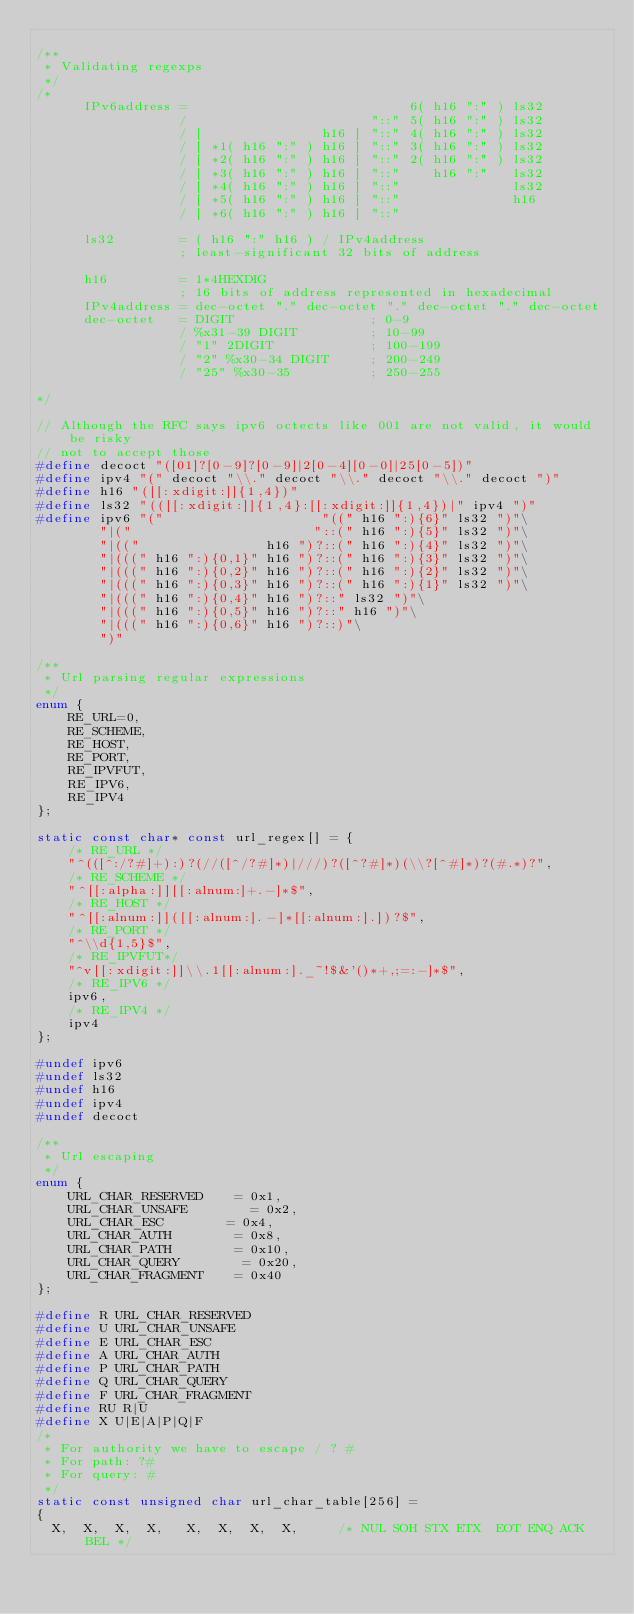<code> <loc_0><loc_0><loc_500><loc_500><_C_>
/**
 * Validating regexps
 */
/*
      IPv6address =                            6( h16 ":" ) ls32
                  /                       "::" 5( h16 ":" ) ls32
                  / [               h16 ] "::" 4( h16 ":" ) ls32
                  / [ *1( h16 ":" ) h16 ] "::" 3( h16 ":" ) ls32
                  / [ *2( h16 ":" ) h16 ] "::" 2( h16 ":" ) ls32
                  / [ *3( h16 ":" ) h16 ] "::"    h16 ":"   ls32
                  / [ *4( h16 ":" ) h16 ] "::"              ls32
                  / [ *5( h16 ":" ) h16 ] "::"              h16
                  / [ *6( h16 ":" ) h16 ] "::"

      ls32        = ( h16 ":" h16 ) / IPv4address
                  ; least-significant 32 bits of address

      h16         = 1*4HEXDIG
                  ; 16 bits of address represented in hexadecimal
      IPv4address = dec-octet "." dec-octet "." dec-octet "." dec-octet
      dec-octet   = DIGIT                 ; 0-9
                  / %x31-39 DIGIT         ; 10-99
                  / "1" 2DIGIT            ; 100-199
                  / "2" %x30-34 DIGIT     ; 200-249
                  / "25" %x30-35          ; 250-255

*/

// Although the RFC says ipv6 octects like 001 are not valid, it would be risky
// not to accept those
#define decoct "([01]?[0-9]?[0-9]|2[0-4][0-0]|25[0-5])"
#define ipv4 "(" decoct "\\." decoct "\\." decoct "\\." decoct ")"
#define h16 "([[:xdigit:]]{1,4})"
#define ls32 "(([[:xdigit:]]{1,4}:[[:xdigit:]]{1,4})|" ipv4 ")"
#define ipv6 "("                    "((" h16 ":){6}" ls32 ")"\
        "|("                       "::(" h16 ":){5}" ls32 ")"\
        "|(("                h16 ")?::(" h16 ":){4}" ls32 ")"\
        "|(((" h16 ":){0,1}" h16 ")?::(" h16 ":){3}" ls32 ")"\
        "|(((" h16 ":){0,2}" h16 ")?::(" h16 ":){2}" ls32 ")"\
        "|(((" h16 ":){0,3}" h16 ")?::(" h16 ":){1}" ls32 ")"\
        "|(((" h16 ":){0,4}" h16 ")?::" ls32 ")"\
        "|(((" h16 ":){0,5}" h16 ")?::" h16 ")"\
        "|(((" h16 ":){0,6}" h16 ")?::)"\
        ")"

/**
 * Url parsing regular expressions
 */
enum {
    RE_URL=0,
    RE_SCHEME,
    RE_HOST,
    RE_PORT,
    RE_IPVFUT,
    RE_IPV6,
    RE_IPV4
};

static const char* const url_regex[] = {
    /* RE_URL */
    "^(([^:/?#]+):)?(//([^/?#]*)|///)?([^?#]*)(\\?[^#]*)?(#.*)?",
    /* RE_SCHEME */
    "^[[:alpha:]][[:alnum:]+.-]*$",
    /* RE_HOST */
    "^[[:alnum:]]([[:alnum:].-]*[[:alnum:].])?$",
    /* RE_PORT */
    "^\\d{1,5}$",
    /* RE_IPVFUT*/
    "^v[[:xdigit:]]\\.1[[:alnum:]._~!$&'()*+,;=:-]*$",
    /* RE_IPV6 */
    ipv6,
    /* RE_IPV4 */
    ipv4
};

#undef ipv6
#undef ls32
#undef h16
#undef ipv4
#undef decoct

/**
 * Url escaping
 */
enum {
    URL_CHAR_RESERVED    = 0x1,
    URL_CHAR_UNSAFE        = 0x2,
    URL_CHAR_ESC        = 0x4,
    URL_CHAR_AUTH        = 0x8,
    URL_CHAR_PATH        = 0x10,
    URL_CHAR_QUERY        = 0x20,
    URL_CHAR_FRAGMENT    = 0x40
};

#define R URL_CHAR_RESERVED
#define U URL_CHAR_UNSAFE
#define E URL_CHAR_ESC
#define A URL_CHAR_AUTH
#define P URL_CHAR_PATH
#define Q URL_CHAR_QUERY
#define F URL_CHAR_FRAGMENT
#define RU R|U
#define X U|E|A|P|Q|F
/*
 * For authority we have to escape / ? #
 * For path: ?#
 * For query: #
 */
static const unsigned char url_char_table[256] =
{
  X,  X,  X,  X,   X,  X,  X,  X,     /* NUL SOH STX ETX  EOT ENQ ACK BEL */</code> 